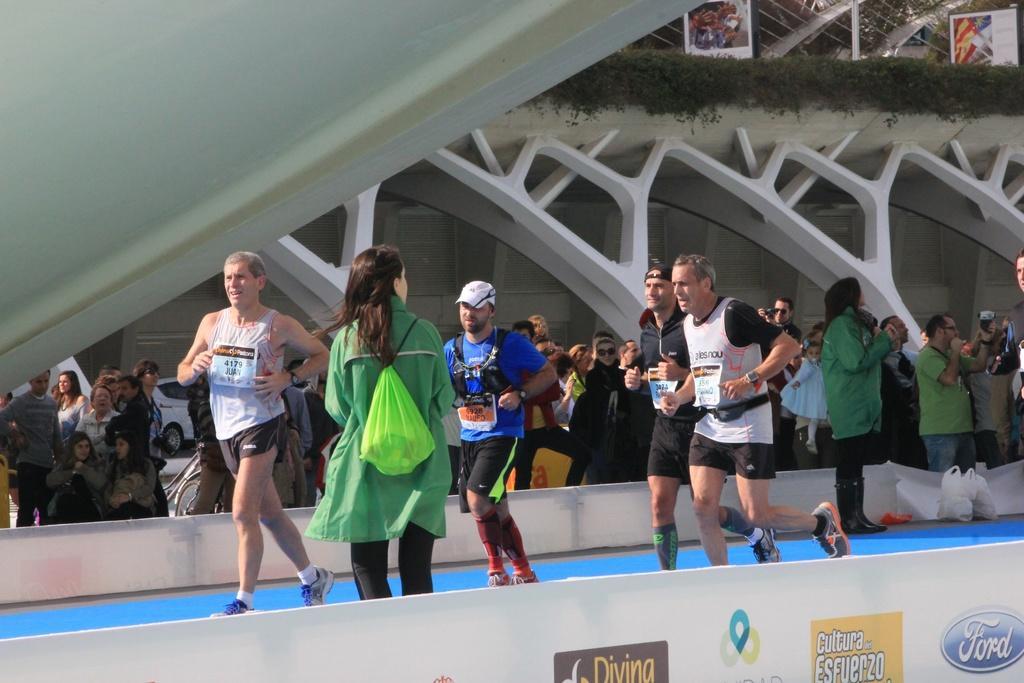Could you give a brief overview of what you see in this image? In this picture, we see four men are running. Beside them, we see a woman in the green jacket is standing. At the bottom, we see a board in white color with some text written on it. Behind them, we see the people are standing. Behind them, we see a white car. On the left side, we see a white wall. In the background, we see a building. At the top, we see the roof of the building and the boards in white color. We see the creeper plants. 